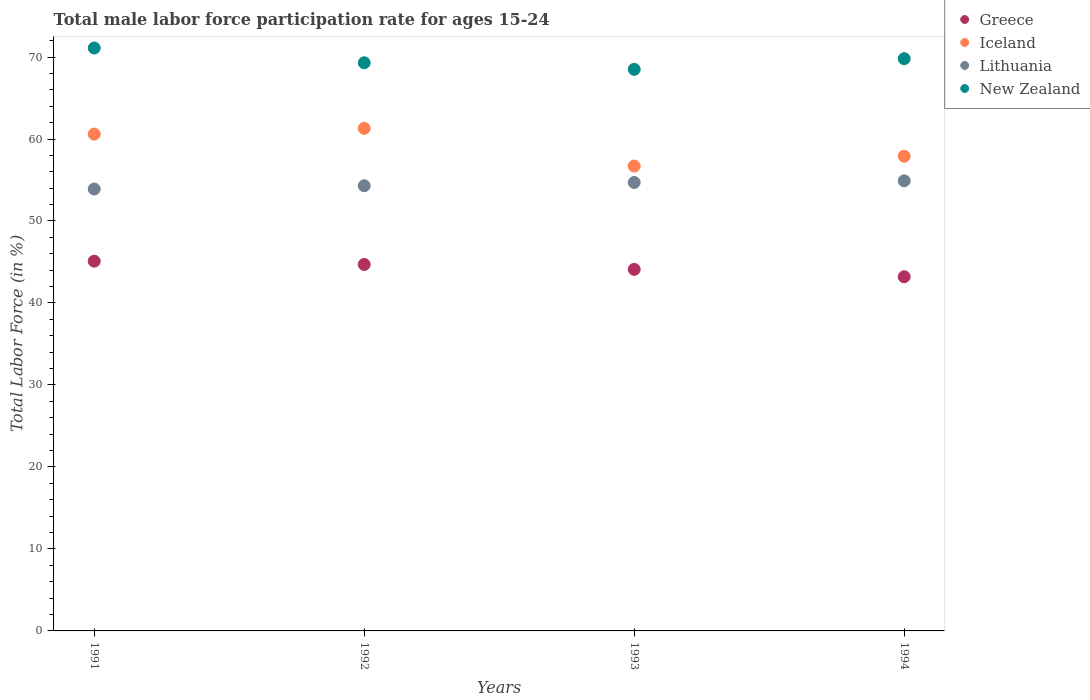What is the male labor force participation rate in New Zealand in 1991?
Give a very brief answer. 71.1. Across all years, what is the maximum male labor force participation rate in Iceland?
Your answer should be compact. 61.3. Across all years, what is the minimum male labor force participation rate in Lithuania?
Give a very brief answer. 53.9. In which year was the male labor force participation rate in Lithuania minimum?
Make the answer very short. 1991. What is the total male labor force participation rate in New Zealand in the graph?
Your answer should be very brief. 278.7. What is the difference between the male labor force participation rate in New Zealand in 1992 and that in 1993?
Offer a very short reply. 0.8. What is the difference between the male labor force participation rate in Greece in 1993 and the male labor force participation rate in New Zealand in 1991?
Offer a very short reply. -27. What is the average male labor force participation rate in New Zealand per year?
Your answer should be very brief. 69.68. In the year 1994, what is the difference between the male labor force participation rate in Lithuania and male labor force participation rate in Iceland?
Offer a very short reply. -3. In how many years, is the male labor force participation rate in Greece greater than 4 %?
Give a very brief answer. 4. What is the ratio of the male labor force participation rate in Greece in 1993 to that in 1994?
Offer a very short reply. 1.02. Is the difference between the male labor force participation rate in Lithuania in 1992 and 1994 greater than the difference between the male labor force participation rate in Iceland in 1992 and 1994?
Your response must be concise. No. What is the difference between the highest and the second highest male labor force participation rate in Greece?
Your answer should be very brief. 0.4. In how many years, is the male labor force participation rate in Lithuania greater than the average male labor force participation rate in Lithuania taken over all years?
Provide a succinct answer. 2. Is the male labor force participation rate in New Zealand strictly greater than the male labor force participation rate in Greece over the years?
Keep it short and to the point. Yes. Is the male labor force participation rate in Iceland strictly less than the male labor force participation rate in Greece over the years?
Give a very brief answer. No. How many dotlines are there?
Your response must be concise. 4. How many years are there in the graph?
Keep it short and to the point. 4. What is the difference between two consecutive major ticks on the Y-axis?
Keep it short and to the point. 10. Are the values on the major ticks of Y-axis written in scientific E-notation?
Offer a very short reply. No. Where does the legend appear in the graph?
Keep it short and to the point. Top right. How many legend labels are there?
Provide a short and direct response. 4. What is the title of the graph?
Offer a terse response. Total male labor force participation rate for ages 15-24. What is the label or title of the X-axis?
Your answer should be very brief. Years. What is the Total Labor Force (in %) of Greece in 1991?
Your answer should be very brief. 45.1. What is the Total Labor Force (in %) of Iceland in 1991?
Give a very brief answer. 60.6. What is the Total Labor Force (in %) of Lithuania in 1991?
Ensure brevity in your answer.  53.9. What is the Total Labor Force (in %) in New Zealand in 1991?
Your answer should be very brief. 71.1. What is the Total Labor Force (in %) of Greece in 1992?
Keep it short and to the point. 44.7. What is the Total Labor Force (in %) of Iceland in 1992?
Ensure brevity in your answer.  61.3. What is the Total Labor Force (in %) of Lithuania in 1992?
Ensure brevity in your answer.  54.3. What is the Total Labor Force (in %) of New Zealand in 1992?
Offer a very short reply. 69.3. What is the Total Labor Force (in %) of Greece in 1993?
Your response must be concise. 44.1. What is the Total Labor Force (in %) of Iceland in 1993?
Make the answer very short. 56.7. What is the Total Labor Force (in %) in Lithuania in 1993?
Your response must be concise. 54.7. What is the Total Labor Force (in %) of New Zealand in 1993?
Your answer should be compact. 68.5. What is the Total Labor Force (in %) in Greece in 1994?
Give a very brief answer. 43.2. What is the Total Labor Force (in %) in Iceland in 1994?
Make the answer very short. 57.9. What is the Total Labor Force (in %) of Lithuania in 1994?
Keep it short and to the point. 54.9. What is the Total Labor Force (in %) of New Zealand in 1994?
Provide a short and direct response. 69.8. Across all years, what is the maximum Total Labor Force (in %) in Greece?
Give a very brief answer. 45.1. Across all years, what is the maximum Total Labor Force (in %) in Iceland?
Keep it short and to the point. 61.3. Across all years, what is the maximum Total Labor Force (in %) in Lithuania?
Provide a succinct answer. 54.9. Across all years, what is the maximum Total Labor Force (in %) in New Zealand?
Provide a succinct answer. 71.1. Across all years, what is the minimum Total Labor Force (in %) in Greece?
Your answer should be very brief. 43.2. Across all years, what is the minimum Total Labor Force (in %) of Iceland?
Offer a very short reply. 56.7. Across all years, what is the minimum Total Labor Force (in %) of Lithuania?
Provide a short and direct response. 53.9. Across all years, what is the minimum Total Labor Force (in %) in New Zealand?
Make the answer very short. 68.5. What is the total Total Labor Force (in %) in Greece in the graph?
Provide a succinct answer. 177.1. What is the total Total Labor Force (in %) in Iceland in the graph?
Provide a short and direct response. 236.5. What is the total Total Labor Force (in %) of Lithuania in the graph?
Give a very brief answer. 217.8. What is the total Total Labor Force (in %) of New Zealand in the graph?
Ensure brevity in your answer.  278.7. What is the difference between the Total Labor Force (in %) of Iceland in 1991 and that in 1992?
Your answer should be very brief. -0.7. What is the difference between the Total Labor Force (in %) of New Zealand in 1991 and that in 1992?
Offer a very short reply. 1.8. What is the difference between the Total Labor Force (in %) in Greece in 1991 and that in 1993?
Provide a succinct answer. 1. What is the difference between the Total Labor Force (in %) in Iceland in 1991 and that in 1993?
Ensure brevity in your answer.  3.9. What is the difference between the Total Labor Force (in %) in Lithuania in 1991 and that in 1993?
Offer a terse response. -0.8. What is the difference between the Total Labor Force (in %) in Iceland in 1991 and that in 1994?
Your answer should be compact. 2.7. What is the difference between the Total Labor Force (in %) of Lithuania in 1991 and that in 1994?
Ensure brevity in your answer.  -1. What is the difference between the Total Labor Force (in %) in New Zealand in 1991 and that in 1994?
Provide a short and direct response. 1.3. What is the difference between the Total Labor Force (in %) in Lithuania in 1992 and that in 1993?
Make the answer very short. -0.4. What is the difference between the Total Labor Force (in %) in New Zealand in 1992 and that in 1993?
Give a very brief answer. 0.8. What is the difference between the Total Labor Force (in %) of Greece in 1992 and that in 1994?
Ensure brevity in your answer.  1.5. What is the difference between the Total Labor Force (in %) in Iceland in 1992 and that in 1994?
Ensure brevity in your answer.  3.4. What is the difference between the Total Labor Force (in %) in New Zealand in 1993 and that in 1994?
Your answer should be very brief. -1.3. What is the difference between the Total Labor Force (in %) of Greece in 1991 and the Total Labor Force (in %) of Iceland in 1992?
Your answer should be compact. -16.2. What is the difference between the Total Labor Force (in %) of Greece in 1991 and the Total Labor Force (in %) of New Zealand in 1992?
Your response must be concise. -24.2. What is the difference between the Total Labor Force (in %) in Lithuania in 1991 and the Total Labor Force (in %) in New Zealand in 1992?
Offer a very short reply. -15.4. What is the difference between the Total Labor Force (in %) of Greece in 1991 and the Total Labor Force (in %) of Iceland in 1993?
Your answer should be compact. -11.6. What is the difference between the Total Labor Force (in %) of Greece in 1991 and the Total Labor Force (in %) of Lithuania in 1993?
Keep it short and to the point. -9.6. What is the difference between the Total Labor Force (in %) in Greece in 1991 and the Total Labor Force (in %) in New Zealand in 1993?
Offer a very short reply. -23.4. What is the difference between the Total Labor Force (in %) of Iceland in 1991 and the Total Labor Force (in %) of New Zealand in 1993?
Make the answer very short. -7.9. What is the difference between the Total Labor Force (in %) of Lithuania in 1991 and the Total Labor Force (in %) of New Zealand in 1993?
Make the answer very short. -14.6. What is the difference between the Total Labor Force (in %) in Greece in 1991 and the Total Labor Force (in %) in Iceland in 1994?
Your response must be concise. -12.8. What is the difference between the Total Labor Force (in %) of Greece in 1991 and the Total Labor Force (in %) of Lithuania in 1994?
Provide a short and direct response. -9.8. What is the difference between the Total Labor Force (in %) in Greece in 1991 and the Total Labor Force (in %) in New Zealand in 1994?
Your response must be concise. -24.7. What is the difference between the Total Labor Force (in %) of Iceland in 1991 and the Total Labor Force (in %) of Lithuania in 1994?
Provide a short and direct response. 5.7. What is the difference between the Total Labor Force (in %) of Lithuania in 1991 and the Total Labor Force (in %) of New Zealand in 1994?
Your response must be concise. -15.9. What is the difference between the Total Labor Force (in %) in Greece in 1992 and the Total Labor Force (in %) in Iceland in 1993?
Your answer should be compact. -12. What is the difference between the Total Labor Force (in %) in Greece in 1992 and the Total Labor Force (in %) in Lithuania in 1993?
Your answer should be very brief. -10. What is the difference between the Total Labor Force (in %) of Greece in 1992 and the Total Labor Force (in %) of New Zealand in 1993?
Your answer should be compact. -23.8. What is the difference between the Total Labor Force (in %) in Iceland in 1992 and the Total Labor Force (in %) in Lithuania in 1993?
Your response must be concise. 6.6. What is the difference between the Total Labor Force (in %) in Iceland in 1992 and the Total Labor Force (in %) in New Zealand in 1993?
Your answer should be very brief. -7.2. What is the difference between the Total Labor Force (in %) in Greece in 1992 and the Total Labor Force (in %) in Iceland in 1994?
Your answer should be compact. -13.2. What is the difference between the Total Labor Force (in %) in Greece in 1992 and the Total Labor Force (in %) in Lithuania in 1994?
Ensure brevity in your answer.  -10.2. What is the difference between the Total Labor Force (in %) of Greece in 1992 and the Total Labor Force (in %) of New Zealand in 1994?
Your answer should be very brief. -25.1. What is the difference between the Total Labor Force (in %) of Iceland in 1992 and the Total Labor Force (in %) of Lithuania in 1994?
Your answer should be very brief. 6.4. What is the difference between the Total Labor Force (in %) of Lithuania in 1992 and the Total Labor Force (in %) of New Zealand in 1994?
Your answer should be compact. -15.5. What is the difference between the Total Labor Force (in %) of Greece in 1993 and the Total Labor Force (in %) of Lithuania in 1994?
Your answer should be very brief. -10.8. What is the difference between the Total Labor Force (in %) of Greece in 1993 and the Total Labor Force (in %) of New Zealand in 1994?
Your response must be concise. -25.7. What is the difference between the Total Labor Force (in %) of Lithuania in 1993 and the Total Labor Force (in %) of New Zealand in 1994?
Offer a very short reply. -15.1. What is the average Total Labor Force (in %) in Greece per year?
Offer a terse response. 44.27. What is the average Total Labor Force (in %) in Iceland per year?
Your response must be concise. 59.12. What is the average Total Labor Force (in %) of Lithuania per year?
Make the answer very short. 54.45. What is the average Total Labor Force (in %) of New Zealand per year?
Make the answer very short. 69.67. In the year 1991, what is the difference between the Total Labor Force (in %) of Greece and Total Labor Force (in %) of Iceland?
Offer a very short reply. -15.5. In the year 1991, what is the difference between the Total Labor Force (in %) of Iceland and Total Labor Force (in %) of Lithuania?
Ensure brevity in your answer.  6.7. In the year 1991, what is the difference between the Total Labor Force (in %) of Lithuania and Total Labor Force (in %) of New Zealand?
Your answer should be very brief. -17.2. In the year 1992, what is the difference between the Total Labor Force (in %) in Greece and Total Labor Force (in %) in Iceland?
Provide a succinct answer. -16.6. In the year 1992, what is the difference between the Total Labor Force (in %) in Greece and Total Labor Force (in %) in Lithuania?
Your response must be concise. -9.6. In the year 1992, what is the difference between the Total Labor Force (in %) in Greece and Total Labor Force (in %) in New Zealand?
Give a very brief answer. -24.6. In the year 1992, what is the difference between the Total Labor Force (in %) in Iceland and Total Labor Force (in %) in Lithuania?
Keep it short and to the point. 7. In the year 1992, what is the difference between the Total Labor Force (in %) in Iceland and Total Labor Force (in %) in New Zealand?
Your answer should be compact. -8. In the year 1992, what is the difference between the Total Labor Force (in %) in Lithuania and Total Labor Force (in %) in New Zealand?
Provide a succinct answer. -15. In the year 1993, what is the difference between the Total Labor Force (in %) in Greece and Total Labor Force (in %) in Lithuania?
Your response must be concise. -10.6. In the year 1993, what is the difference between the Total Labor Force (in %) in Greece and Total Labor Force (in %) in New Zealand?
Your response must be concise. -24.4. In the year 1993, what is the difference between the Total Labor Force (in %) in Iceland and Total Labor Force (in %) in Lithuania?
Offer a very short reply. 2. In the year 1993, what is the difference between the Total Labor Force (in %) in Lithuania and Total Labor Force (in %) in New Zealand?
Your answer should be very brief. -13.8. In the year 1994, what is the difference between the Total Labor Force (in %) of Greece and Total Labor Force (in %) of Iceland?
Your answer should be very brief. -14.7. In the year 1994, what is the difference between the Total Labor Force (in %) of Greece and Total Labor Force (in %) of New Zealand?
Offer a very short reply. -26.6. In the year 1994, what is the difference between the Total Labor Force (in %) in Iceland and Total Labor Force (in %) in New Zealand?
Provide a short and direct response. -11.9. In the year 1994, what is the difference between the Total Labor Force (in %) of Lithuania and Total Labor Force (in %) of New Zealand?
Your response must be concise. -14.9. What is the ratio of the Total Labor Force (in %) of Greece in 1991 to that in 1992?
Ensure brevity in your answer.  1.01. What is the ratio of the Total Labor Force (in %) in New Zealand in 1991 to that in 1992?
Your answer should be very brief. 1.03. What is the ratio of the Total Labor Force (in %) of Greece in 1991 to that in 1993?
Give a very brief answer. 1.02. What is the ratio of the Total Labor Force (in %) of Iceland in 1991 to that in 1993?
Provide a succinct answer. 1.07. What is the ratio of the Total Labor Force (in %) in Lithuania in 1991 to that in 1993?
Offer a terse response. 0.99. What is the ratio of the Total Labor Force (in %) in New Zealand in 1991 to that in 1993?
Give a very brief answer. 1.04. What is the ratio of the Total Labor Force (in %) of Greece in 1991 to that in 1994?
Provide a succinct answer. 1.04. What is the ratio of the Total Labor Force (in %) in Iceland in 1991 to that in 1994?
Your response must be concise. 1.05. What is the ratio of the Total Labor Force (in %) of Lithuania in 1991 to that in 1994?
Offer a terse response. 0.98. What is the ratio of the Total Labor Force (in %) in New Zealand in 1991 to that in 1994?
Your answer should be very brief. 1.02. What is the ratio of the Total Labor Force (in %) in Greece in 1992 to that in 1993?
Offer a very short reply. 1.01. What is the ratio of the Total Labor Force (in %) of Iceland in 1992 to that in 1993?
Your answer should be compact. 1.08. What is the ratio of the Total Labor Force (in %) of New Zealand in 1992 to that in 1993?
Your answer should be compact. 1.01. What is the ratio of the Total Labor Force (in %) of Greece in 1992 to that in 1994?
Your response must be concise. 1.03. What is the ratio of the Total Labor Force (in %) of Iceland in 1992 to that in 1994?
Your answer should be very brief. 1.06. What is the ratio of the Total Labor Force (in %) in Greece in 1993 to that in 1994?
Keep it short and to the point. 1.02. What is the ratio of the Total Labor Force (in %) in Iceland in 1993 to that in 1994?
Your response must be concise. 0.98. What is the ratio of the Total Labor Force (in %) of New Zealand in 1993 to that in 1994?
Provide a succinct answer. 0.98. What is the difference between the highest and the second highest Total Labor Force (in %) of New Zealand?
Offer a terse response. 1.3. What is the difference between the highest and the lowest Total Labor Force (in %) in Greece?
Provide a short and direct response. 1.9. What is the difference between the highest and the lowest Total Labor Force (in %) in Iceland?
Offer a very short reply. 4.6. What is the difference between the highest and the lowest Total Labor Force (in %) in Lithuania?
Provide a succinct answer. 1. What is the difference between the highest and the lowest Total Labor Force (in %) of New Zealand?
Provide a succinct answer. 2.6. 